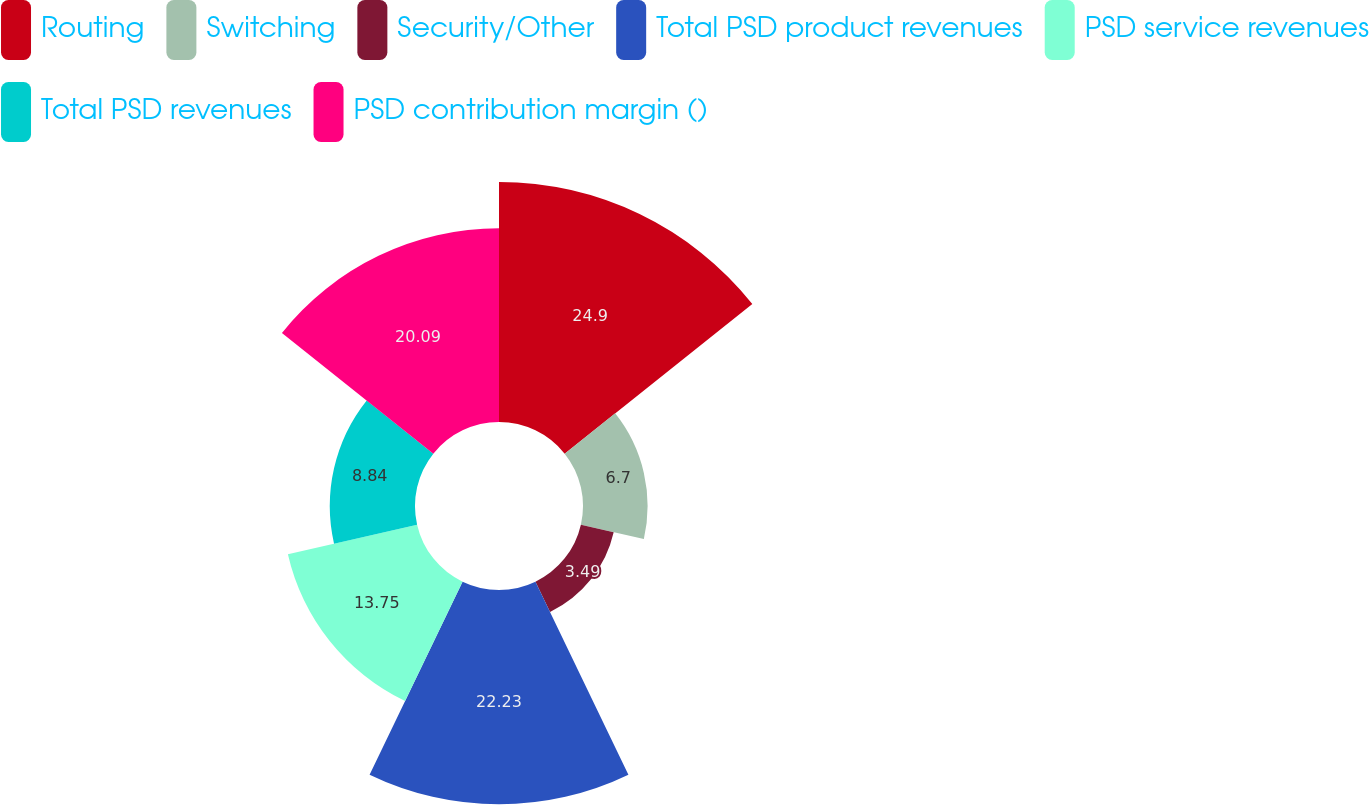Convert chart to OTSL. <chart><loc_0><loc_0><loc_500><loc_500><pie_chart><fcel>Routing<fcel>Switching<fcel>Security/Other<fcel>Total PSD product revenues<fcel>PSD service revenues<fcel>Total PSD revenues<fcel>PSD contribution margin ()<nl><fcel>24.9%<fcel>6.7%<fcel>3.49%<fcel>22.23%<fcel>13.75%<fcel>8.84%<fcel>20.09%<nl></chart> 